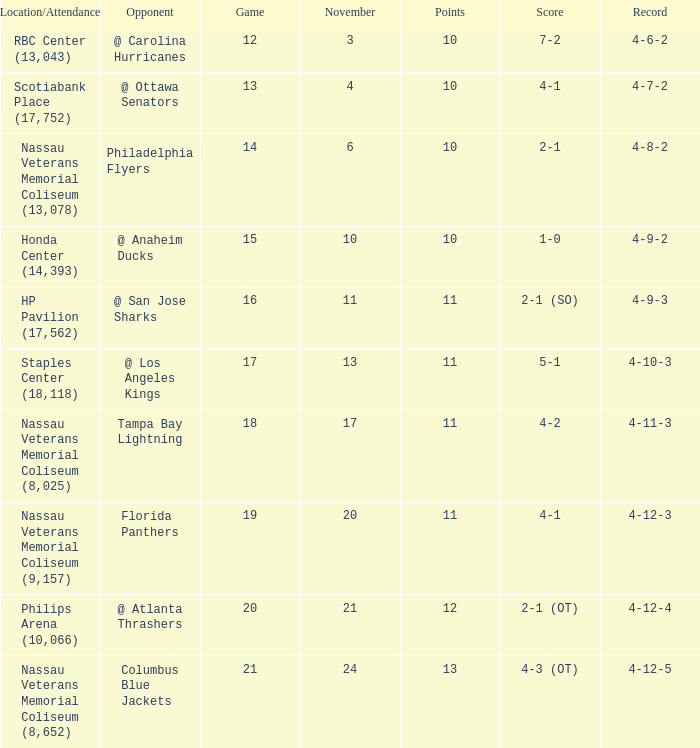What is every game on November 21? 20.0. 